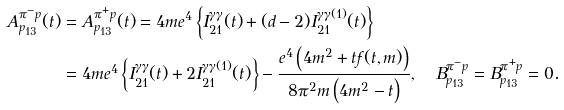<formula> <loc_0><loc_0><loc_500><loc_500>A _ { p _ { 1 3 } } ^ { \pi ^ { - } p } ( t ) & = A _ { p _ { 1 3 } } ^ { \pi ^ { + } p } ( t ) = 4 m e ^ { 4 } \left \{ I _ { 2 1 } ^ { \gamma \gamma } ( t ) + ( d - 2 ) I _ { 2 1 } ^ { \gamma \gamma ( 1 ) } ( t ) \right \} \\ & = 4 m e ^ { 4 } \left \{ I _ { 2 1 } ^ { \gamma \gamma } ( t ) + 2 I _ { 2 1 } ^ { \gamma \gamma ( 1 ) } ( t ) \right \} - \frac { e ^ { 4 } \left ( 4 m ^ { 2 } + t f ( t , m ) \right ) } { 8 \pi ^ { 2 } m \left ( 4 m ^ { 2 } - t \right ) } , \quad B _ { p _ { 1 3 } } ^ { \pi ^ { - } p } = B _ { p _ { 1 3 } } ^ { \pi ^ { + } p } = 0 .</formula> 